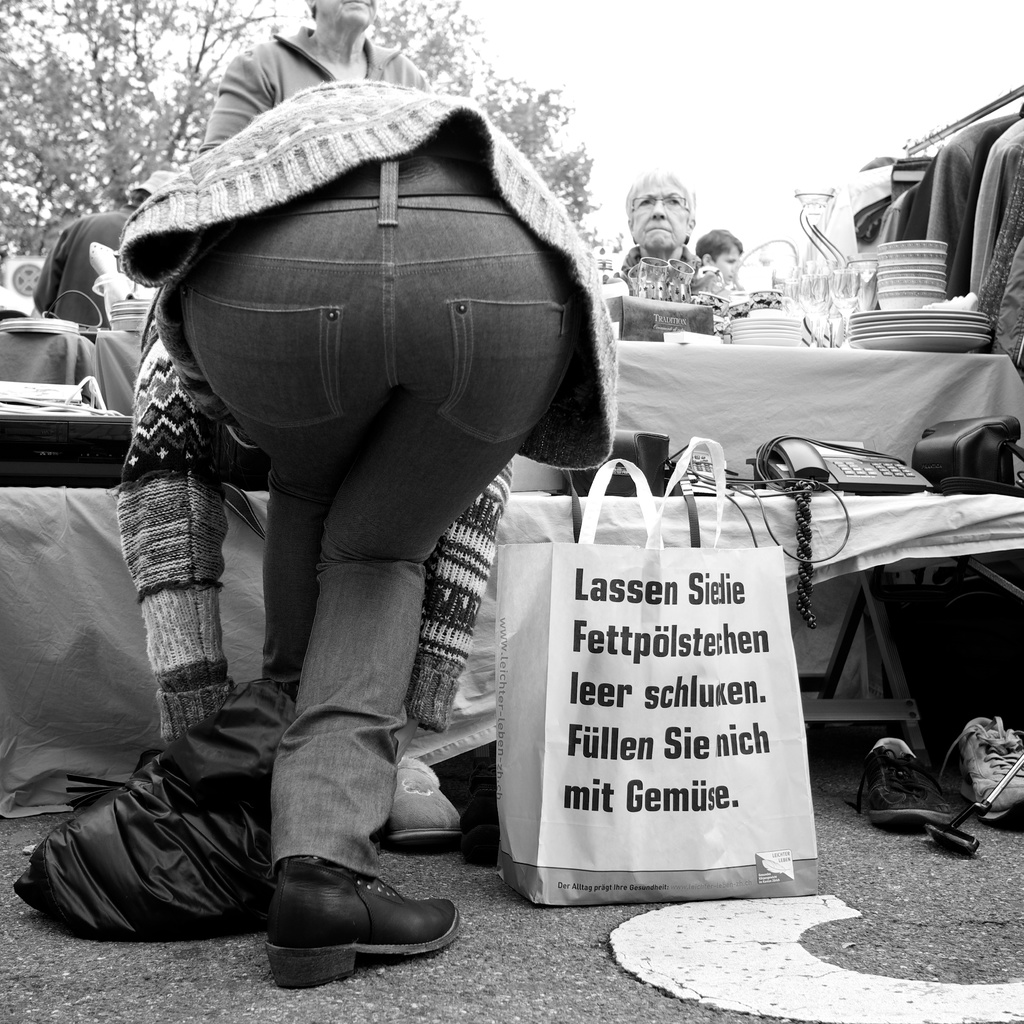Explain the visual content of the image in great detail. This striking black and white photograph portrays a busy moment at a flea market. The composition focuses on a central figure, dressed in jeans and a hooded sweater, bent over as they peruse items on a stall. This person is holding a bag with an intriguing German phrase which could be a humorous or satirical comment. The stalls around them are laden with varied goods, possibly antiques or everyday items, contributing to the vibrant and crowded atmosphere typical of such markets. Other attendees, seemingly absorbed in their own browsing, add to the dynamic feel of the market scene. 